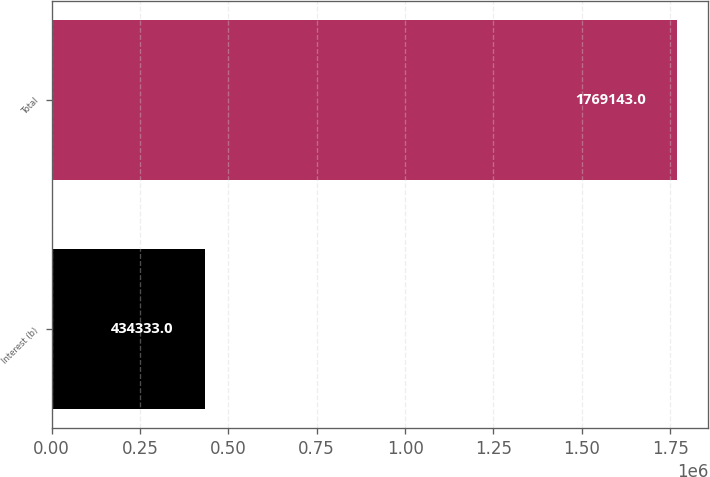Convert chart to OTSL. <chart><loc_0><loc_0><loc_500><loc_500><bar_chart><fcel>Interest (b)<fcel>Total<nl><fcel>434333<fcel>1.76914e+06<nl></chart> 